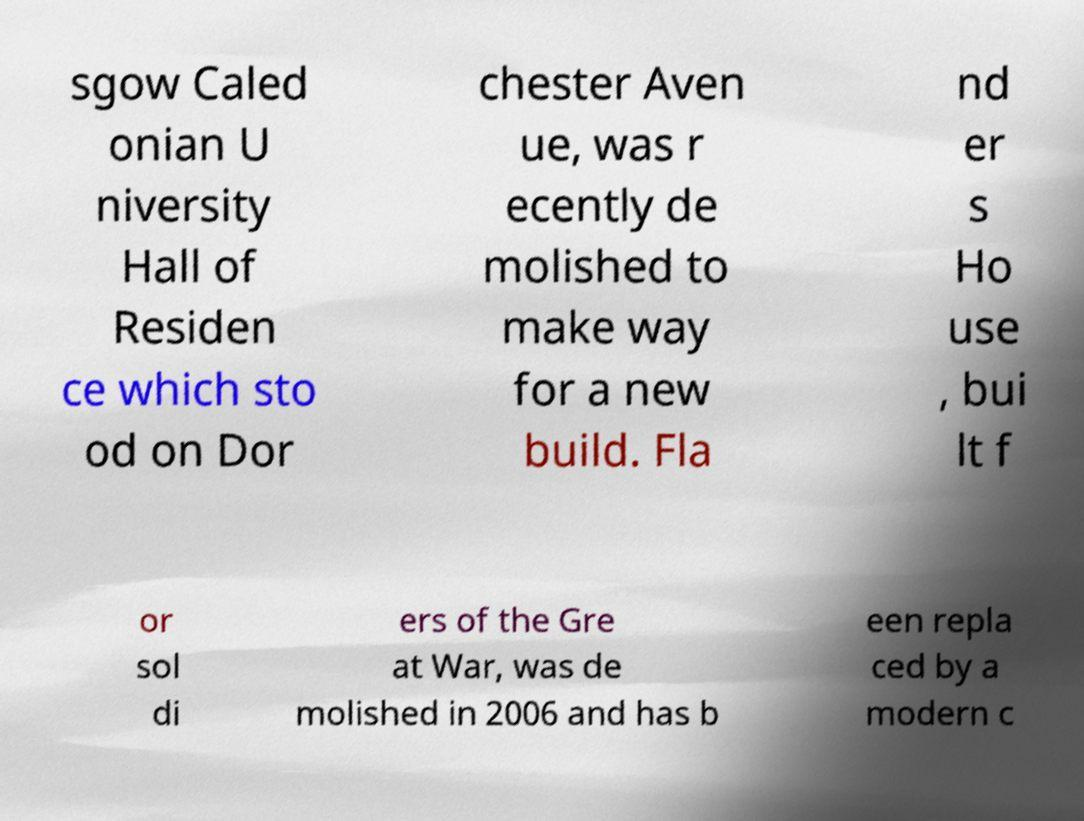What messages or text are displayed in this image? I need them in a readable, typed format. sgow Caled onian U niversity Hall of Residen ce which sto od on Dor chester Aven ue, was r ecently de molished to make way for a new build. Fla nd er s Ho use , bui lt f or sol di ers of the Gre at War, was de molished in 2006 and has b een repla ced by a modern c 